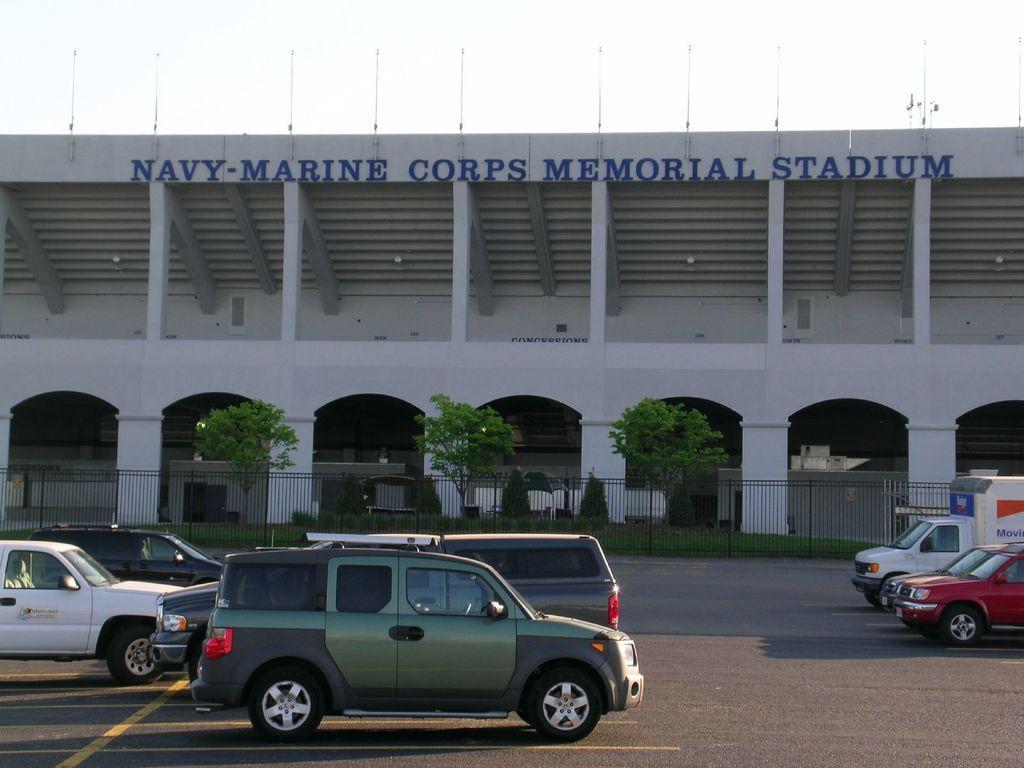How would you summarize this image in a sentence or two? At the bottom of the image I can see few vehicles on the road. On the other side of the road there is a railing. At the back of it, I can see few trees and building. At the top of the building I can see some text. 